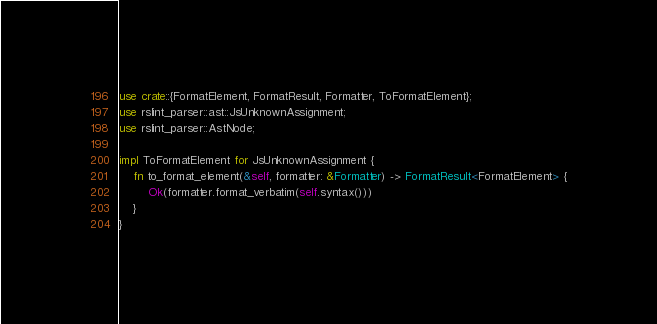<code> <loc_0><loc_0><loc_500><loc_500><_Rust_>use crate::{FormatElement, FormatResult, Formatter, ToFormatElement};
use rslint_parser::ast::JsUnknownAssignment;
use rslint_parser::AstNode;

impl ToFormatElement for JsUnknownAssignment {
    fn to_format_element(&self, formatter: &Formatter) -> FormatResult<FormatElement> {
        Ok(formatter.format_verbatim(self.syntax()))
    }
}
</code> 